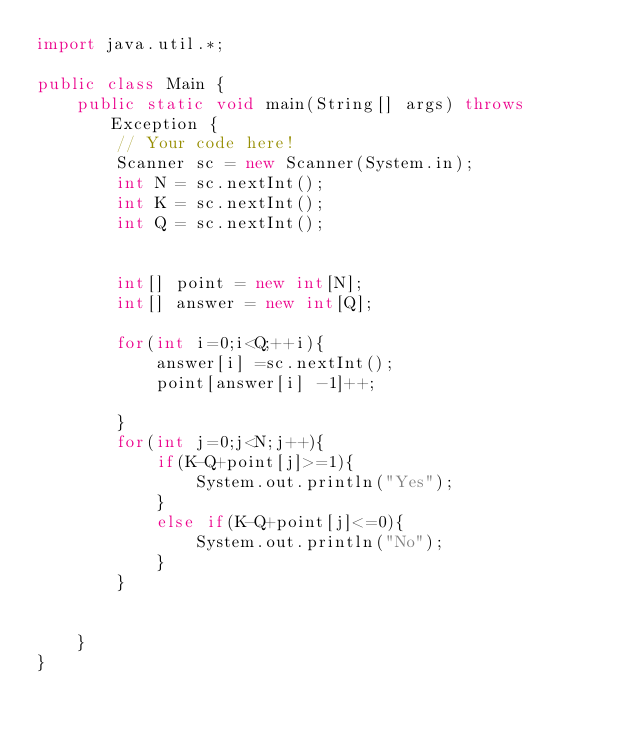Convert code to text. <code><loc_0><loc_0><loc_500><loc_500><_Java_>import java.util.*;

public class Main {
    public static void main(String[] args) throws Exception {
        // Your code here!
        Scanner sc = new Scanner(System.in);
        int N = sc.nextInt();
        int K = sc.nextInt();
        int Q = sc.nextInt();
        
        
        int[] point = new int[N];
        int[] answer = new int[Q];
    
        for(int i=0;i<Q;++i){
            answer[i] =sc.nextInt();
            point[answer[i] -1]++;
            
        }
        for(int j=0;j<N;j++){
            if(K-Q+point[j]>=1){
                System.out.println("Yes");
            }
            else if(K-Q+point[j]<=0){
                System.out.println("No");
            }
        }
        
        
    }
}</code> 